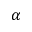<formula> <loc_0><loc_0><loc_500><loc_500>\alpha</formula> 